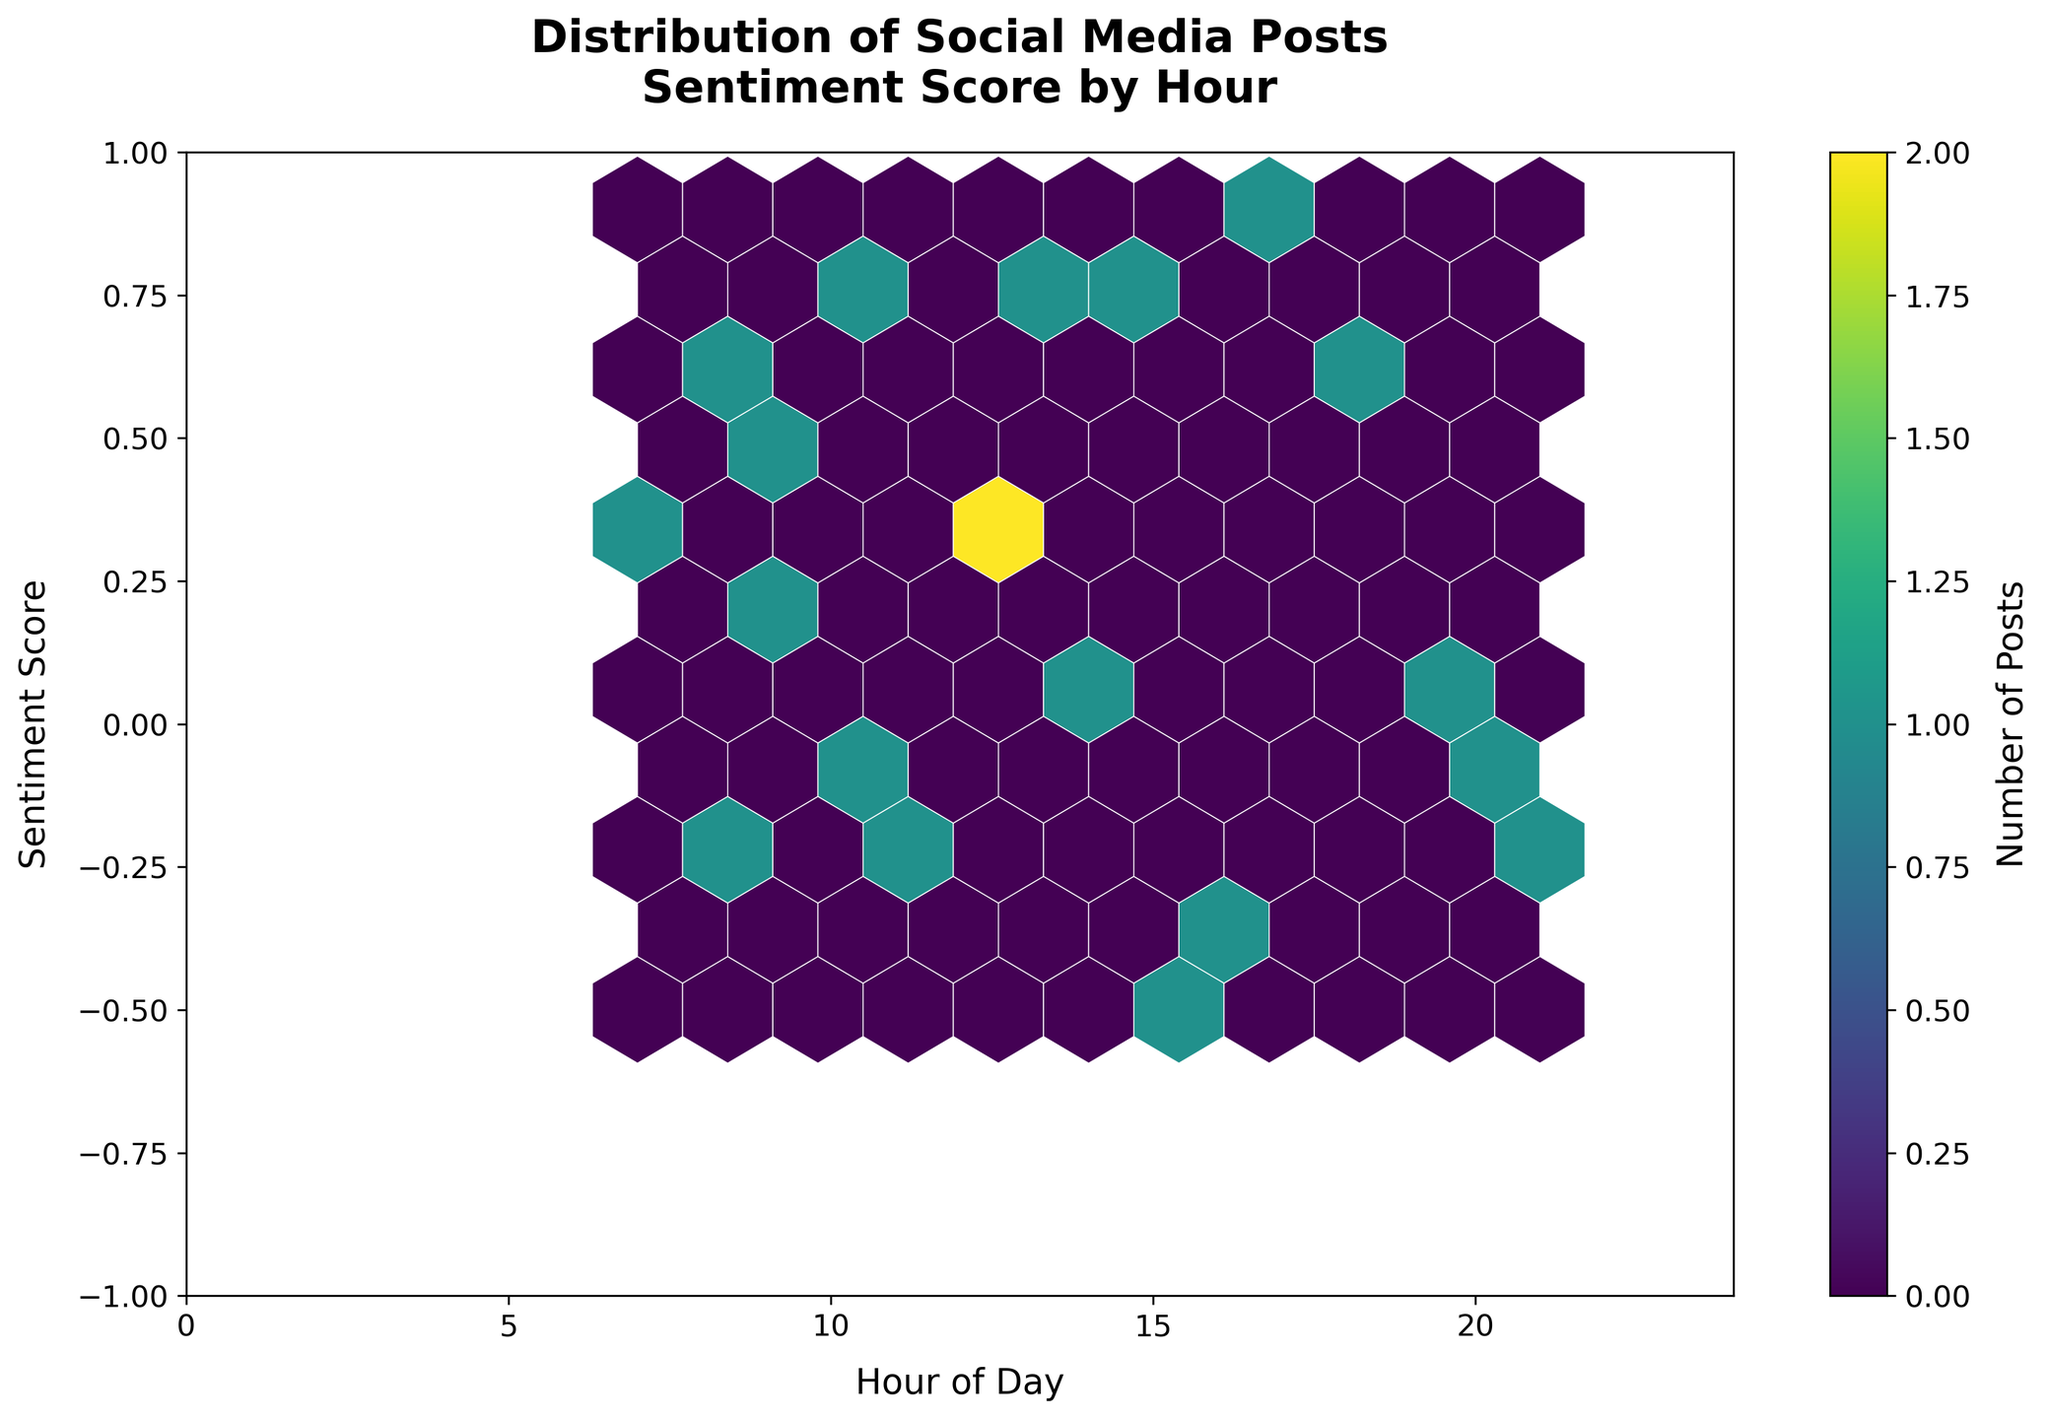What is the title of the plot? The title of the plot is clearly displayed at the top.
Answer: Distribution of Social Media Posts Sentiment Score by Hour What time range does the x-axis cover? The x-axis represents the hour of the day, ranging from 0 (midnight) to 24 (the end of the day).
Answer: 0 to 24 What is the range of sentiment scores on the y-axis? The y-axis shows the sentiment score, ranging from -1 to 1.
Answer: -1 to 1 Which hour has the highest concentration of posts? The hour with the highest concentration of posts can be identified by the darkest hexagon on the x-axis.
Answer: 8 AM What does the color of the hexagons represent? The color of the hexagons, illustrated by the color bar on the right, represents the number of posts within that range. Darker colors indicate higher numbers.
Answer: Number of Posts Around what time do we see the sentiment scores being mostly positive? By observing the distribution of posts around positive sentiment scores on the y-axis, we can identify the hour ranges where positive sentiments are more concentrated.
Answer: Between 8 AM and 12 PM How does the number of posts around noon compare to those in the evening? Compare the darkness of the hexagons around the noon and evening hours; lighter hexagons indicate fewer posts.
Answer: More posts around noon Which hour of the day has the widest range of sentiment scores? Look for the hour with hexagons spanning the widest vertical range on the y-axis.
Answer: Around 10 AM What is the average sentiment score for the hour with the highest concentration of posts? Identify the hour with the highest concentration of posts, observe the distribution of sentiment scores within that hour, and calculate the average. Given near equal distribution around 0.3 and 0.4.
Answer: Approx 0.35 